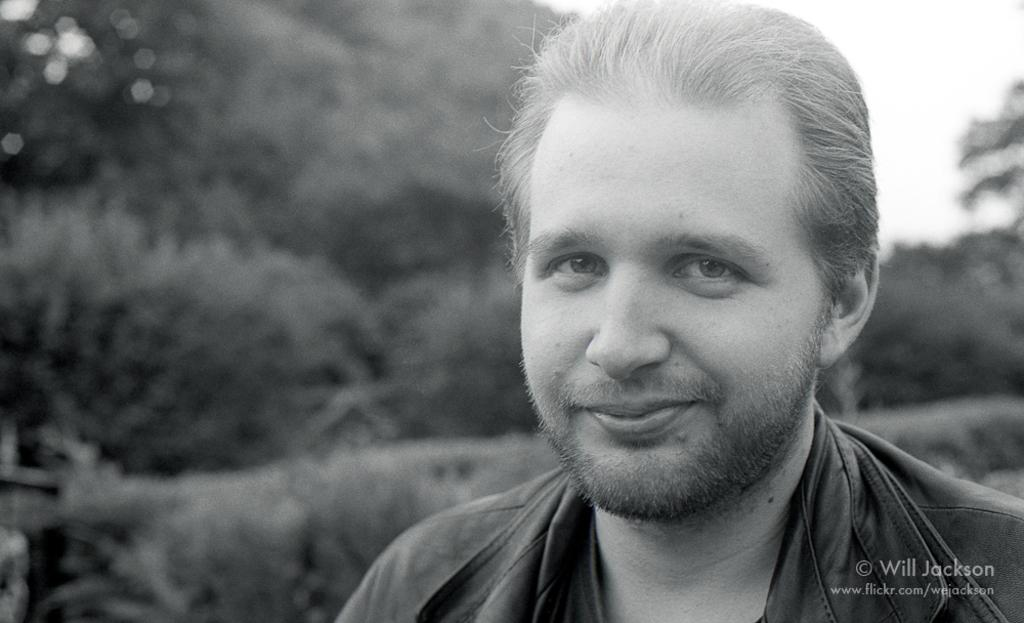Who is present in the image? There is a man in the image. What can be seen in the background of the image? There are trees and the sky visible in the background of the image. What type of lace is being used to decorate the trees in the image? There is no lace present in the image; the trees are not decorated. 